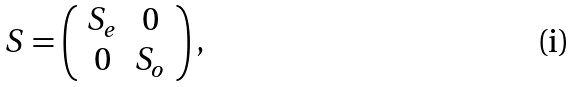Convert formula to latex. <formula><loc_0><loc_0><loc_500><loc_500>S = \left ( \begin{array} { c c } S _ { e } & 0 \\ 0 & S _ { o } \end{array} \right ) ,</formula> 